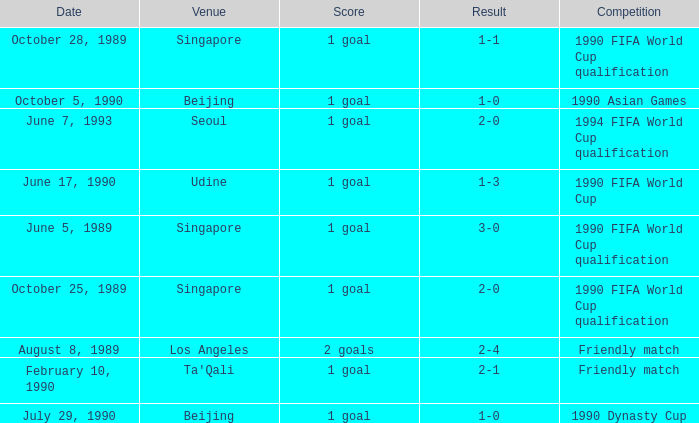What is the score of the match on October 5, 1990? 1 goal. 